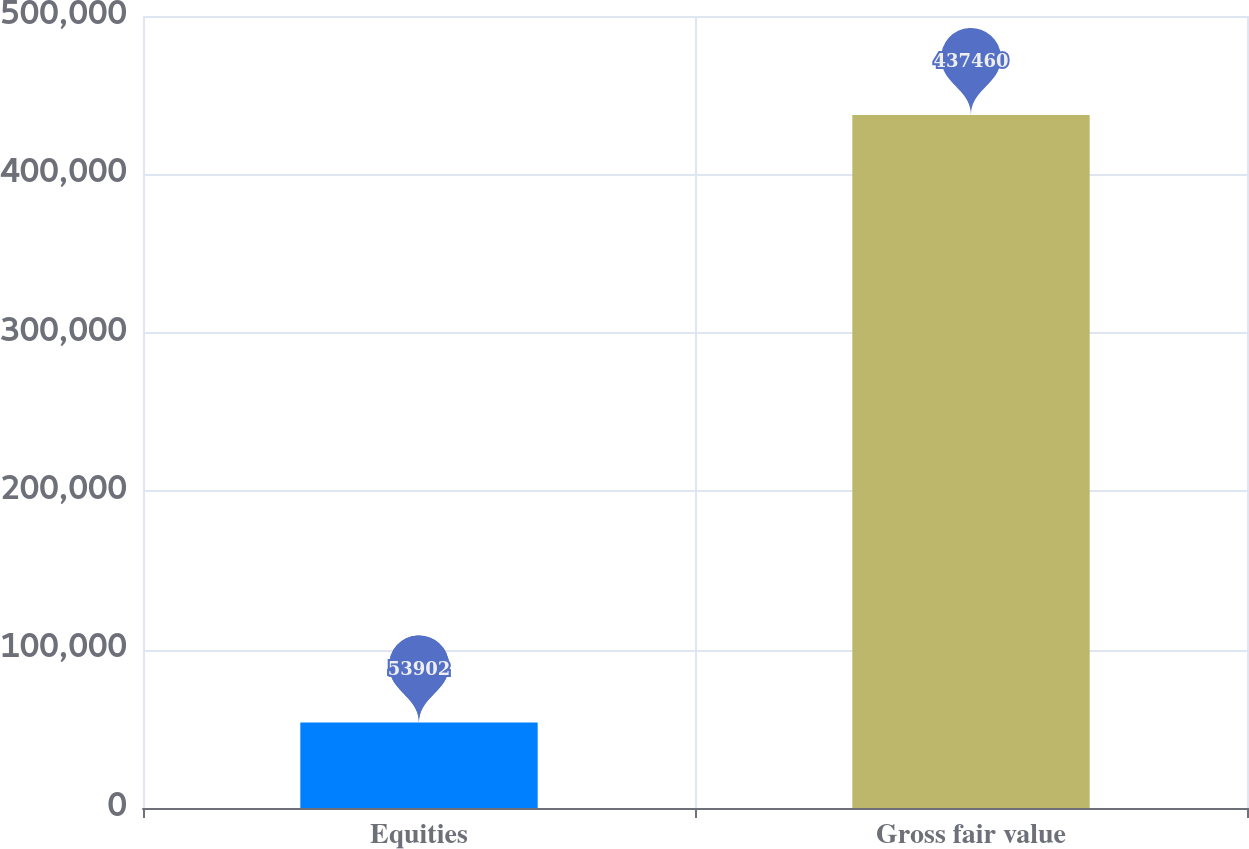Convert chart to OTSL. <chart><loc_0><loc_0><loc_500><loc_500><bar_chart><fcel>Equities<fcel>Gross fair value<nl><fcel>53902<fcel>437460<nl></chart> 